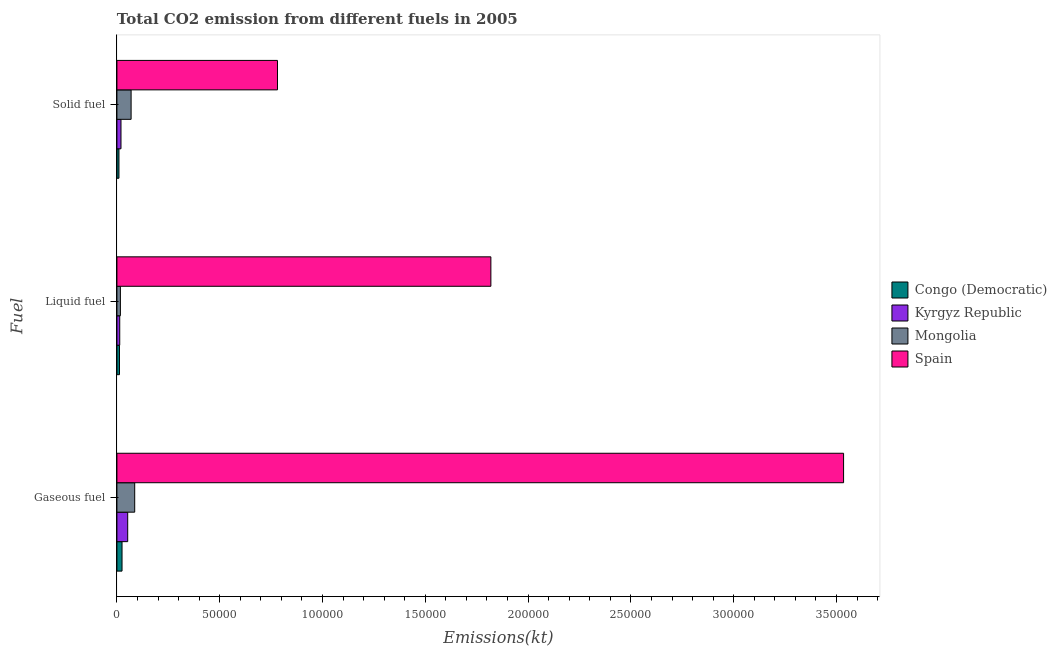How many different coloured bars are there?
Offer a terse response. 4. How many groups of bars are there?
Provide a succinct answer. 3. Are the number of bars on each tick of the Y-axis equal?
Offer a very short reply. Yes. How many bars are there on the 3rd tick from the bottom?
Your answer should be compact. 4. What is the label of the 2nd group of bars from the top?
Provide a short and direct response. Liquid fuel. What is the amount of co2 emissions from solid fuel in Mongolia?
Offer a very short reply. 6901.29. Across all countries, what is the maximum amount of co2 emissions from gaseous fuel?
Your answer should be compact. 3.53e+05. Across all countries, what is the minimum amount of co2 emissions from solid fuel?
Keep it short and to the point. 986.42. In which country was the amount of co2 emissions from gaseous fuel maximum?
Provide a short and direct response. Spain. In which country was the amount of co2 emissions from gaseous fuel minimum?
Keep it short and to the point. Congo (Democratic). What is the total amount of co2 emissions from gaseous fuel in the graph?
Offer a very short reply. 3.70e+05. What is the difference between the amount of co2 emissions from solid fuel in Congo (Democratic) and that in Kyrgyz Republic?
Offer a very short reply. -990.09. What is the difference between the amount of co2 emissions from solid fuel in Kyrgyz Republic and the amount of co2 emissions from liquid fuel in Spain?
Your response must be concise. -1.80e+05. What is the average amount of co2 emissions from solid fuel per country?
Make the answer very short. 2.20e+04. What is the difference between the amount of co2 emissions from solid fuel and amount of co2 emissions from liquid fuel in Kyrgyz Republic?
Give a very brief answer. 605.05. In how many countries, is the amount of co2 emissions from gaseous fuel greater than 130000 kt?
Provide a short and direct response. 1. What is the ratio of the amount of co2 emissions from solid fuel in Kyrgyz Republic to that in Spain?
Make the answer very short. 0.03. What is the difference between the highest and the second highest amount of co2 emissions from gaseous fuel?
Give a very brief answer. 3.45e+05. What is the difference between the highest and the lowest amount of co2 emissions from solid fuel?
Your answer should be very brief. 7.71e+04. In how many countries, is the amount of co2 emissions from gaseous fuel greater than the average amount of co2 emissions from gaseous fuel taken over all countries?
Provide a succinct answer. 1. What does the 1st bar from the top in Liquid fuel represents?
Keep it short and to the point. Spain. What does the 2nd bar from the bottom in Gaseous fuel represents?
Your answer should be very brief. Kyrgyz Republic. Is it the case that in every country, the sum of the amount of co2 emissions from gaseous fuel and amount of co2 emissions from liquid fuel is greater than the amount of co2 emissions from solid fuel?
Your response must be concise. Yes. How many countries are there in the graph?
Your answer should be compact. 4. Does the graph contain any zero values?
Your answer should be very brief. No. Does the graph contain grids?
Your response must be concise. No. How are the legend labels stacked?
Your answer should be very brief. Vertical. What is the title of the graph?
Give a very brief answer. Total CO2 emission from different fuels in 2005. Does "Sierra Leone" appear as one of the legend labels in the graph?
Your answer should be very brief. No. What is the label or title of the X-axis?
Keep it short and to the point. Emissions(kt). What is the label or title of the Y-axis?
Your answer should be compact. Fuel. What is the Emissions(kt) of Congo (Democratic) in Gaseous fuel?
Your answer should be compact. 2486.23. What is the Emissions(kt) of Kyrgyz Republic in Gaseous fuel?
Provide a succinct answer. 5247.48. What is the Emissions(kt) of Mongolia in Gaseous fuel?
Offer a terse response. 8646.79. What is the Emissions(kt) in Spain in Gaseous fuel?
Offer a very short reply. 3.53e+05. What is the Emissions(kt) in Congo (Democratic) in Liquid fuel?
Ensure brevity in your answer.  1239.45. What is the Emissions(kt) in Kyrgyz Republic in Liquid fuel?
Give a very brief answer. 1371.46. What is the Emissions(kt) of Mongolia in Liquid fuel?
Ensure brevity in your answer.  1686.82. What is the Emissions(kt) in Spain in Liquid fuel?
Your answer should be very brief. 1.82e+05. What is the Emissions(kt) of Congo (Democratic) in Solid fuel?
Keep it short and to the point. 986.42. What is the Emissions(kt) of Kyrgyz Republic in Solid fuel?
Make the answer very short. 1976.51. What is the Emissions(kt) of Mongolia in Solid fuel?
Offer a very short reply. 6901.29. What is the Emissions(kt) in Spain in Solid fuel?
Provide a succinct answer. 7.81e+04. Across all Fuel, what is the maximum Emissions(kt) of Congo (Democratic)?
Your response must be concise. 2486.23. Across all Fuel, what is the maximum Emissions(kt) of Kyrgyz Republic?
Your answer should be compact. 5247.48. Across all Fuel, what is the maximum Emissions(kt) in Mongolia?
Provide a short and direct response. 8646.79. Across all Fuel, what is the maximum Emissions(kt) of Spain?
Your answer should be compact. 3.53e+05. Across all Fuel, what is the minimum Emissions(kt) in Congo (Democratic)?
Ensure brevity in your answer.  986.42. Across all Fuel, what is the minimum Emissions(kt) of Kyrgyz Republic?
Keep it short and to the point. 1371.46. Across all Fuel, what is the minimum Emissions(kt) in Mongolia?
Your answer should be compact. 1686.82. Across all Fuel, what is the minimum Emissions(kt) in Spain?
Offer a very short reply. 7.81e+04. What is the total Emissions(kt) in Congo (Democratic) in the graph?
Your response must be concise. 4712.1. What is the total Emissions(kt) of Kyrgyz Republic in the graph?
Provide a short and direct response. 8595.45. What is the total Emissions(kt) of Mongolia in the graph?
Keep it short and to the point. 1.72e+04. What is the total Emissions(kt) of Spain in the graph?
Make the answer very short. 6.13e+05. What is the difference between the Emissions(kt) in Congo (Democratic) in Gaseous fuel and that in Liquid fuel?
Offer a terse response. 1246.78. What is the difference between the Emissions(kt) in Kyrgyz Republic in Gaseous fuel and that in Liquid fuel?
Provide a succinct answer. 3876.02. What is the difference between the Emissions(kt) of Mongolia in Gaseous fuel and that in Liquid fuel?
Your answer should be compact. 6959.97. What is the difference between the Emissions(kt) of Spain in Gaseous fuel and that in Liquid fuel?
Make the answer very short. 1.72e+05. What is the difference between the Emissions(kt) of Congo (Democratic) in Gaseous fuel and that in Solid fuel?
Your answer should be very brief. 1499.8. What is the difference between the Emissions(kt) of Kyrgyz Republic in Gaseous fuel and that in Solid fuel?
Give a very brief answer. 3270.96. What is the difference between the Emissions(kt) in Mongolia in Gaseous fuel and that in Solid fuel?
Provide a short and direct response. 1745.49. What is the difference between the Emissions(kt) in Spain in Gaseous fuel and that in Solid fuel?
Offer a very short reply. 2.75e+05. What is the difference between the Emissions(kt) of Congo (Democratic) in Liquid fuel and that in Solid fuel?
Offer a terse response. 253.02. What is the difference between the Emissions(kt) of Kyrgyz Republic in Liquid fuel and that in Solid fuel?
Your response must be concise. -605.05. What is the difference between the Emissions(kt) of Mongolia in Liquid fuel and that in Solid fuel?
Offer a very short reply. -5214.47. What is the difference between the Emissions(kt) of Spain in Liquid fuel and that in Solid fuel?
Provide a succinct answer. 1.04e+05. What is the difference between the Emissions(kt) of Congo (Democratic) in Gaseous fuel and the Emissions(kt) of Kyrgyz Republic in Liquid fuel?
Give a very brief answer. 1114.77. What is the difference between the Emissions(kt) in Congo (Democratic) in Gaseous fuel and the Emissions(kt) in Mongolia in Liquid fuel?
Ensure brevity in your answer.  799.41. What is the difference between the Emissions(kt) of Congo (Democratic) in Gaseous fuel and the Emissions(kt) of Spain in Liquid fuel?
Make the answer very short. -1.79e+05. What is the difference between the Emissions(kt) of Kyrgyz Republic in Gaseous fuel and the Emissions(kt) of Mongolia in Liquid fuel?
Your answer should be compact. 3560.66. What is the difference between the Emissions(kt) in Kyrgyz Republic in Gaseous fuel and the Emissions(kt) in Spain in Liquid fuel?
Ensure brevity in your answer.  -1.77e+05. What is the difference between the Emissions(kt) in Mongolia in Gaseous fuel and the Emissions(kt) in Spain in Liquid fuel?
Your answer should be very brief. -1.73e+05. What is the difference between the Emissions(kt) in Congo (Democratic) in Gaseous fuel and the Emissions(kt) in Kyrgyz Republic in Solid fuel?
Give a very brief answer. 509.71. What is the difference between the Emissions(kt) of Congo (Democratic) in Gaseous fuel and the Emissions(kt) of Mongolia in Solid fuel?
Offer a very short reply. -4415.07. What is the difference between the Emissions(kt) in Congo (Democratic) in Gaseous fuel and the Emissions(kt) in Spain in Solid fuel?
Keep it short and to the point. -7.56e+04. What is the difference between the Emissions(kt) in Kyrgyz Republic in Gaseous fuel and the Emissions(kt) in Mongolia in Solid fuel?
Give a very brief answer. -1653.82. What is the difference between the Emissions(kt) in Kyrgyz Republic in Gaseous fuel and the Emissions(kt) in Spain in Solid fuel?
Ensure brevity in your answer.  -7.29e+04. What is the difference between the Emissions(kt) of Mongolia in Gaseous fuel and the Emissions(kt) of Spain in Solid fuel?
Your response must be concise. -6.95e+04. What is the difference between the Emissions(kt) in Congo (Democratic) in Liquid fuel and the Emissions(kt) in Kyrgyz Republic in Solid fuel?
Keep it short and to the point. -737.07. What is the difference between the Emissions(kt) in Congo (Democratic) in Liquid fuel and the Emissions(kt) in Mongolia in Solid fuel?
Ensure brevity in your answer.  -5661.85. What is the difference between the Emissions(kt) of Congo (Democratic) in Liquid fuel and the Emissions(kt) of Spain in Solid fuel?
Offer a terse response. -7.69e+04. What is the difference between the Emissions(kt) of Kyrgyz Republic in Liquid fuel and the Emissions(kt) of Mongolia in Solid fuel?
Provide a succinct answer. -5529.84. What is the difference between the Emissions(kt) of Kyrgyz Republic in Liquid fuel and the Emissions(kt) of Spain in Solid fuel?
Give a very brief answer. -7.67e+04. What is the difference between the Emissions(kt) in Mongolia in Liquid fuel and the Emissions(kt) in Spain in Solid fuel?
Provide a succinct answer. -7.64e+04. What is the average Emissions(kt) in Congo (Democratic) per Fuel?
Offer a very short reply. 1570.7. What is the average Emissions(kt) in Kyrgyz Republic per Fuel?
Offer a very short reply. 2865.15. What is the average Emissions(kt) in Mongolia per Fuel?
Offer a terse response. 5744.97. What is the average Emissions(kt) in Spain per Fuel?
Make the answer very short. 2.04e+05. What is the difference between the Emissions(kt) of Congo (Democratic) and Emissions(kt) of Kyrgyz Republic in Gaseous fuel?
Make the answer very short. -2761.25. What is the difference between the Emissions(kt) of Congo (Democratic) and Emissions(kt) of Mongolia in Gaseous fuel?
Provide a short and direct response. -6160.56. What is the difference between the Emissions(kt) of Congo (Democratic) and Emissions(kt) of Spain in Gaseous fuel?
Your answer should be compact. -3.51e+05. What is the difference between the Emissions(kt) in Kyrgyz Republic and Emissions(kt) in Mongolia in Gaseous fuel?
Keep it short and to the point. -3399.31. What is the difference between the Emissions(kt) in Kyrgyz Republic and Emissions(kt) in Spain in Gaseous fuel?
Provide a short and direct response. -3.48e+05. What is the difference between the Emissions(kt) of Mongolia and Emissions(kt) of Spain in Gaseous fuel?
Offer a terse response. -3.45e+05. What is the difference between the Emissions(kt) in Congo (Democratic) and Emissions(kt) in Kyrgyz Republic in Liquid fuel?
Make the answer very short. -132.01. What is the difference between the Emissions(kt) of Congo (Democratic) and Emissions(kt) of Mongolia in Liquid fuel?
Provide a succinct answer. -447.37. What is the difference between the Emissions(kt) in Congo (Democratic) and Emissions(kt) in Spain in Liquid fuel?
Make the answer very short. -1.81e+05. What is the difference between the Emissions(kt) in Kyrgyz Republic and Emissions(kt) in Mongolia in Liquid fuel?
Offer a very short reply. -315.36. What is the difference between the Emissions(kt) of Kyrgyz Republic and Emissions(kt) of Spain in Liquid fuel?
Your answer should be compact. -1.81e+05. What is the difference between the Emissions(kt) in Mongolia and Emissions(kt) in Spain in Liquid fuel?
Your response must be concise. -1.80e+05. What is the difference between the Emissions(kt) of Congo (Democratic) and Emissions(kt) of Kyrgyz Republic in Solid fuel?
Make the answer very short. -990.09. What is the difference between the Emissions(kt) of Congo (Democratic) and Emissions(kt) of Mongolia in Solid fuel?
Provide a short and direct response. -5914.87. What is the difference between the Emissions(kt) in Congo (Democratic) and Emissions(kt) in Spain in Solid fuel?
Offer a very short reply. -7.71e+04. What is the difference between the Emissions(kt) of Kyrgyz Republic and Emissions(kt) of Mongolia in Solid fuel?
Your answer should be very brief. -4924.78. What is the difference between the Emissions(kt) of Kyrgyz Republic and Emissions(kt) of Spain in Solid fuel?
Provide a short and direct response. -7.61e+04. What is the difference between the Emissions(kt) of Mongolia and Emissions(kt) of Spain in Solid fuel?
Provide a succinct answer. -7.12e+04. What is the ratio of the Emissions(kt) in Congo (Democratic) in Gaseous fuel to that in Liquid fuel?
Your answer should be compact. 2.01. What is the ratio of the Emissions(kt) in Kyrgyz Republic in Gaseous fuel to that in Liquid fuel?
Ensure brevity in your answer.  3.83. What is the ratio of the Emissions(kt) of Mongolia in Gaseous fuel to that in Liquid fuel?
Your answer should be very brief. 5.13. What is the ratio of the Emissions(kt) of Spain in Gaseous fuel to that in Liquid fuel?
Provide a succinct answer. 1.94. What is the ratio of the Emissions(kt) in Congo (Democratic) in Gaseous fuel to that in Solid fuel?
Make the answer very short. 2.52. What is the ratio of the Emissions(kt) of Kyrgyz Republic in Gaseous fuel to that in Solid fuel?
Offer a very short reply. 2.65. What is the ratio of the Emissions(kt) of Mongolia in Gaseous fuel to that in Solid fuel?
Offer a terse response. 1.25. What is the ratio of the Emissions(kt) of Spain in Gaseous fuel to that in Solid fuel?
Your answer should be compact. 4.53. What is the ratio of the Emissions(kt) of Congo (Democratic) in Liquid fuel to that in Solid fuel?
Give a very brief answer. 1.26. What is the ratio of the Emissions(kt) in Kyrgyz Republic in Liquid fuel to that in Solid fuel?
Your answer should be compact. 0.69. What is the ratio of the Emissions(kt) of Mongolia in Liquid fuel to that in Solid fuel?
Your answer should be very brief. 0.24. What is the ratio of the Emissions(kt) of Spain in Liquid fuel to that in Solid fuel?
Offer a very short reply. 2.33. What is the difference between the highest and the second highest Emissions(kt) of Congo (Democratic)?
Provide a short and direct response. 1246.78. What is the difference between the highest and the second highest Emissions(kt) in Kyrgyz Republic?
Make the answer very short. 3270.96. What is the difference between the highest and the second highest Emissions(kt) in Mongolia?
Make the answer very short. 1745.49. What is the difference between the highest and the second highest Emissions(kt) in Spain?
Make the answer very short. 1.72e+05. What is the difference between the highest and the lowest Emissions(kt) in Congo (Democratic)?
Make the answer very short. 1499.8. What is the difference between the highest and the lowest Emissions(kt) in Kyrgyz Republic?
Keep it short and to the point. 3876.02. What is the difference between the highest and the lowest Emissions(kt) in Mongolia?
Your answer should be compact. 6959.97. What is the difference between the highest and the lowest Emissions(kt) of Spain?
Ensure brevity in your answer.  2.75e+05. 